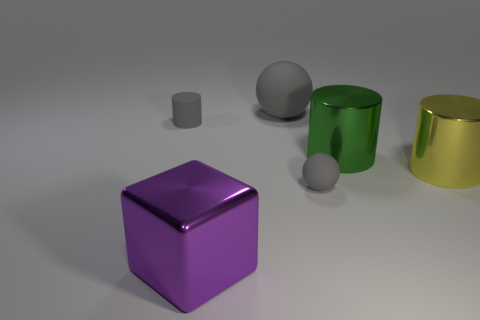Subtract all yellow blocks. Subtract all red cylinders. How many blocks are left? 1 Subtract all yellow spheres. How many red cylinders are left? 0 Add 3 tiny cyans. How many large things exist? 0 Subtract all small blue things. Subtract all green shiny cylinders. How many objects are left? 5 Add 6 large green cylinders. How many large green cylinders are left? 7 Add 6 gray matte spheres. How many gray matte spheres exist? 8 Add 1 small red rubber blocks. How many objects exist? 7 Subtract all yellow cylinders. How many cylinders are left? 2 Subtract all big cylinders. How many cylinders are left? 1 Subtract 0 red cylinders. How many objects are left? 6 